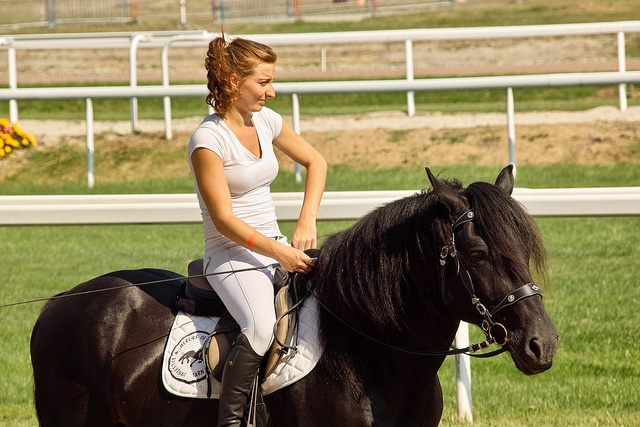Describe the objects in this image and their specific colors. I can see horse in tan, black, lightgray, and gray tones, people in tan, white, and black tones, and potted plant in tan, orange, gold, and olive tones in this image. 